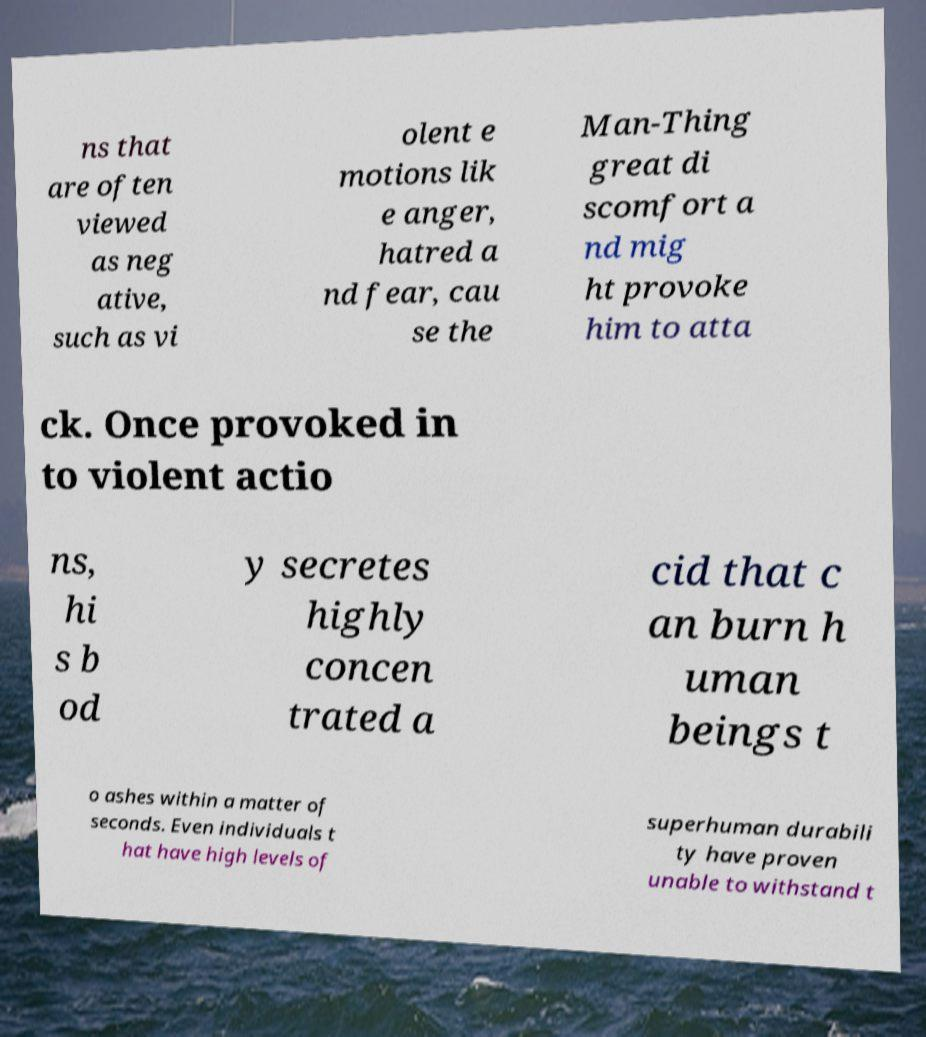For documentation purposes, I need the text within this image transcribed. Could you provide that? ns that are often viewed as neg ative, such as vi olent e motions lik e anger, hatred a nd fear, cau se the Man-Thing great di scomfort a nd mig ht provoke him to atta ck. Once provoked in to violent actio ns, hi s b od y secretes highly concen trated a cid that c an burn h uman beings t o ashes within a matter of seconds. Even individuals t hat have high levels of superhuman durabili ty have proven unable to withstand t 